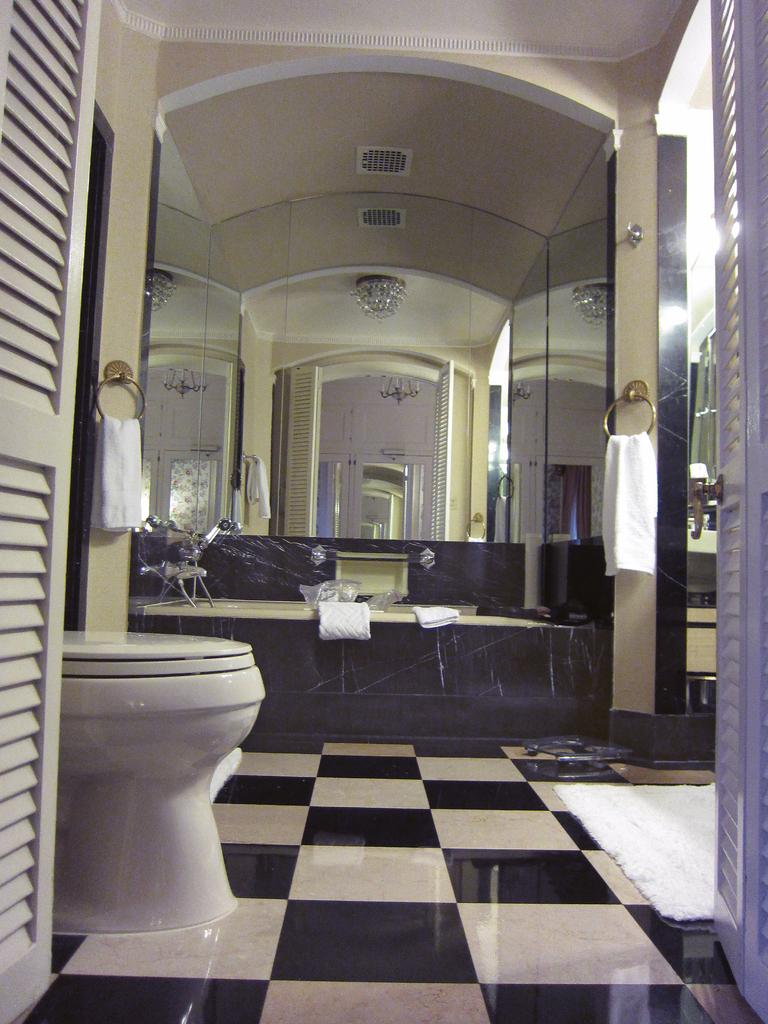What is one of the main objects in the image? There is a mirror in the image. What else can be seen in the image? There are towels in the image. How are the mirror and towels arranged? The mirror is between the towels. What other object is present in the image? There is a toilet seat in the image. Where is the toilet seat located? The toilet seat is in the bottom left of the image. Are there any doors visible in the image? Yes, there is a door on the left side of the image and a door on the right side of the image. What type of stem can be seen growing from the eggnog in the image? There is no eggnog or stem present in the image. Can you describe the park that is visible in the image? There is no park visible in the image. 